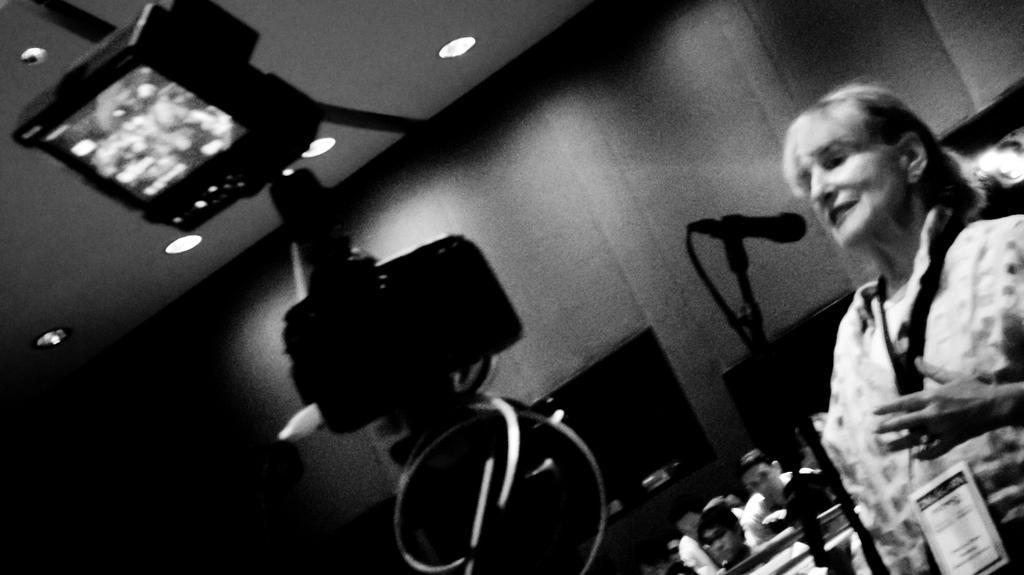How would you summarize this image in a sentence or two? This picture shows a woman standing and speaking with help of a microphone and we see few people seated on the back and we see few lights on the roof and we see a camera to the stand and we see woman wore a id card. 